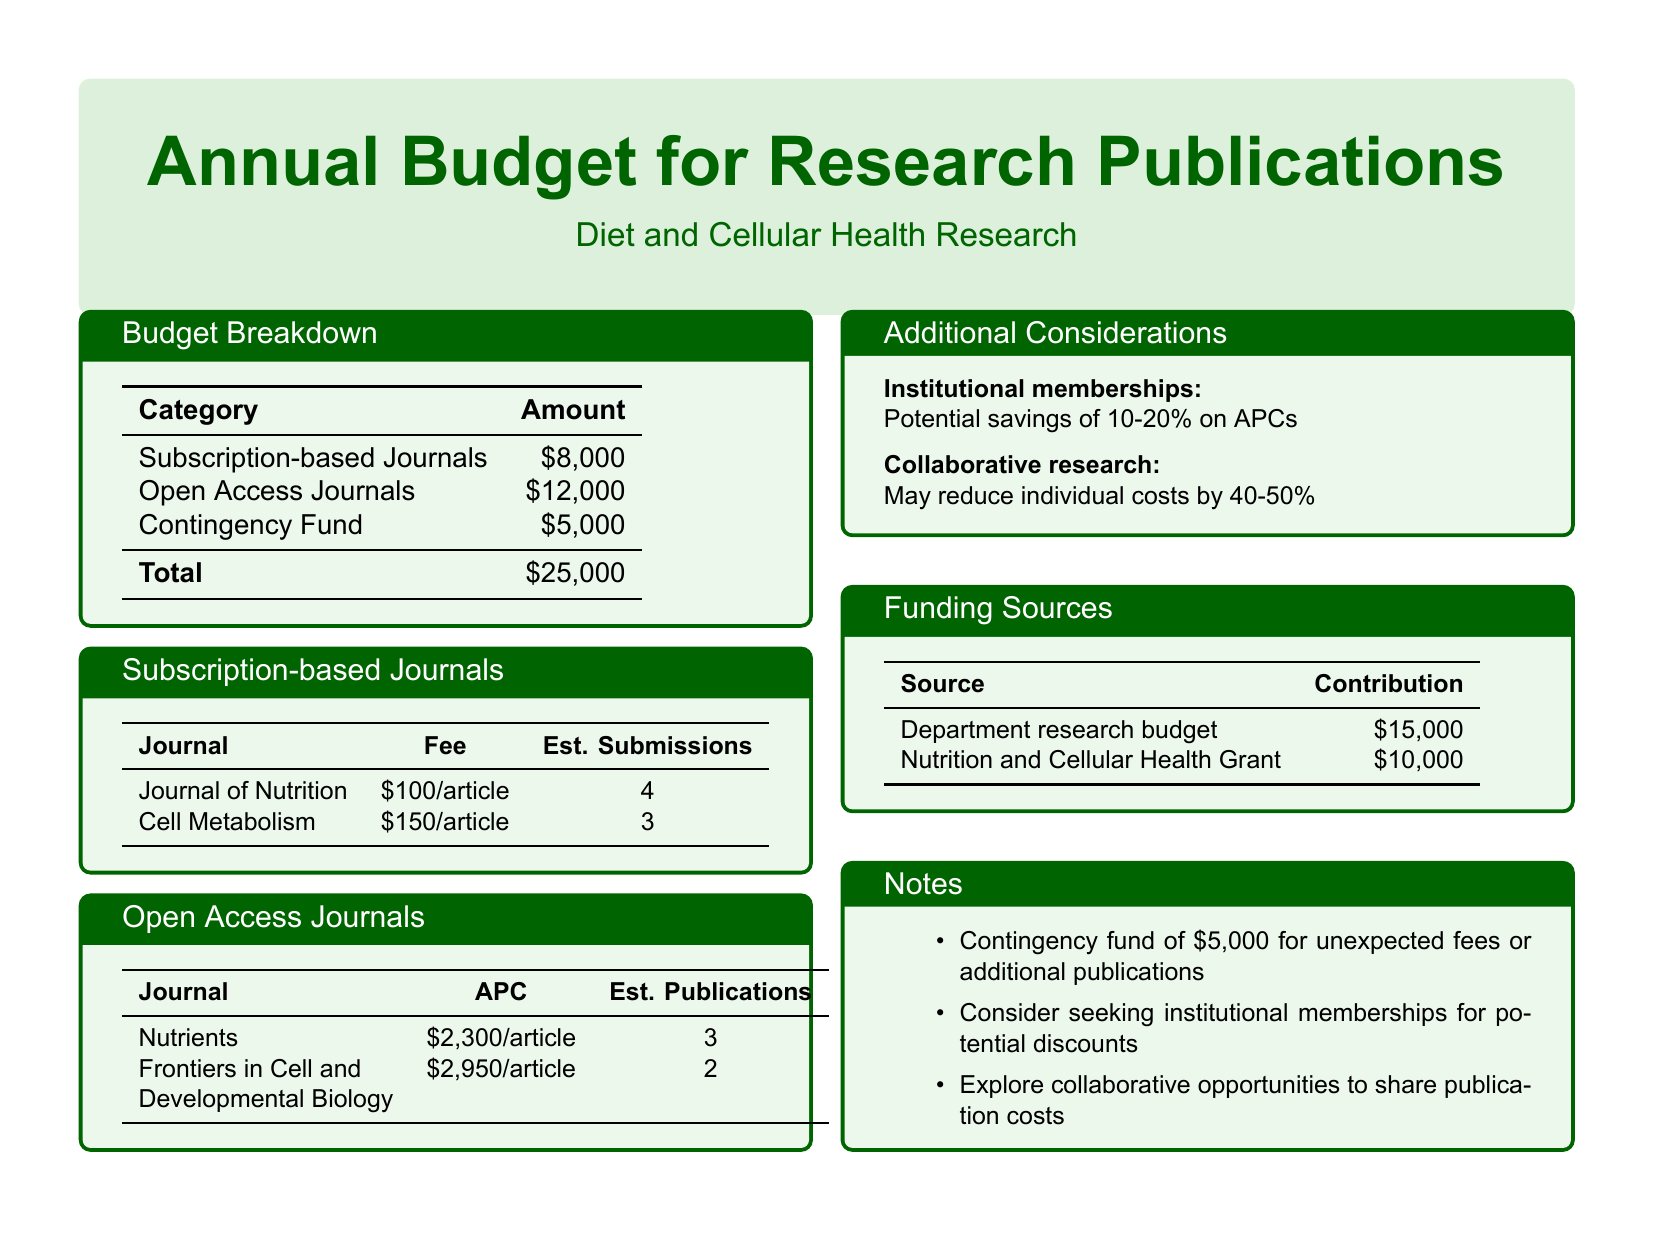What is the total amount allocated for the budget? The total amount is detailed in the Budget Breakdown section, which sums up the different categories to $25,000.
Answer: $25,000 How much is allocated for open access journals? The budget specifically lists $12,000 under the Open Access Journals section.
Answer: $12,000 What is the estimated submission fee for the Journal of Nutrition? The document specifies a fee of $100 per article for the Journal of Nutrition.
Answer: $100/article How many articles are estimated to be submitted to Cell Metabolism? The estimate for submissions to Cell Metabolism is provided as 3 in the document.
Answer: 3 What is the potential savings percentage if institutional memberships are utilized? The document mentions a potential savings of 10-20% on APCs through institutional memberships.
Answer: 10-20% What is the contribution of the Nutrition and Cellular Health Grant to the budget? The document lists the Nutrition and Cellular Health Grant contribution as $10,000.
Answer: $10,000 What contingency fund amount is included in the budget? The document states that there is a contingency fund of $5,000 for unexpected expenses.
Answer: $5,000 How many articles are estimated to be published in Nutrients? The figure given for estimated publications in Nutrients is 3 articles.
Answer: 3 Which category has the highest allocation in the budget? The budget indicates that Open Access Journals have the highest allocation at $12,000.
Answer: Open Access Journals 